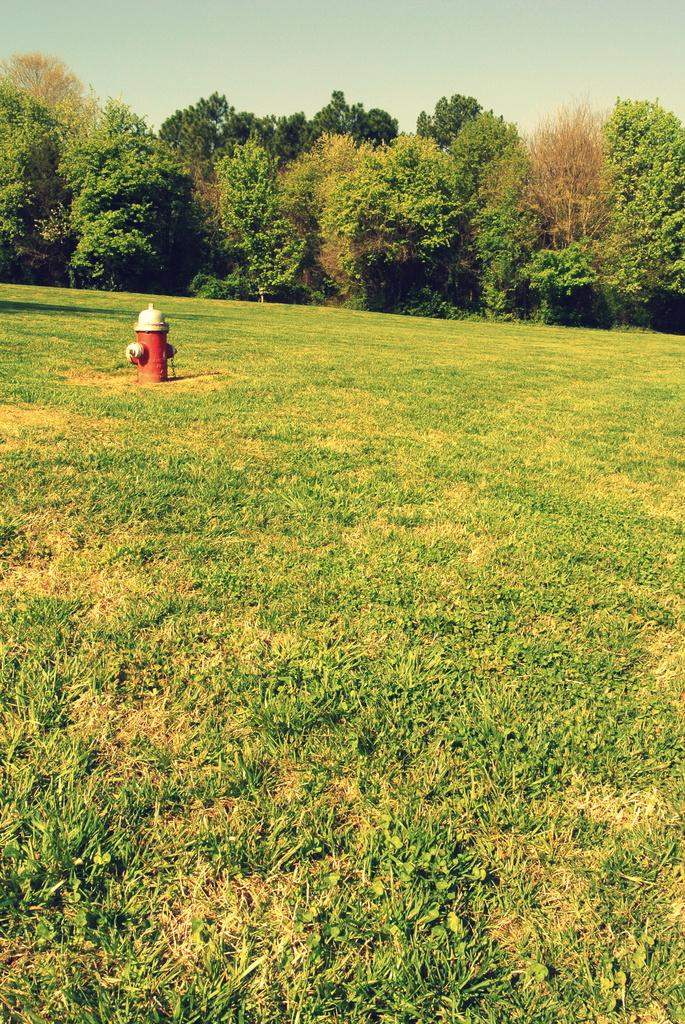What is the main object in the image? There is a water hydrant in the image. What can be seen in the background of the image? There are trees in the background of the image. What type of vegetation is visible in the image? There is grass visible in the image. What color is the curtain hanging in the water hydrant? There is no curtain present in the image; it features a water hydrant and natural elements. 